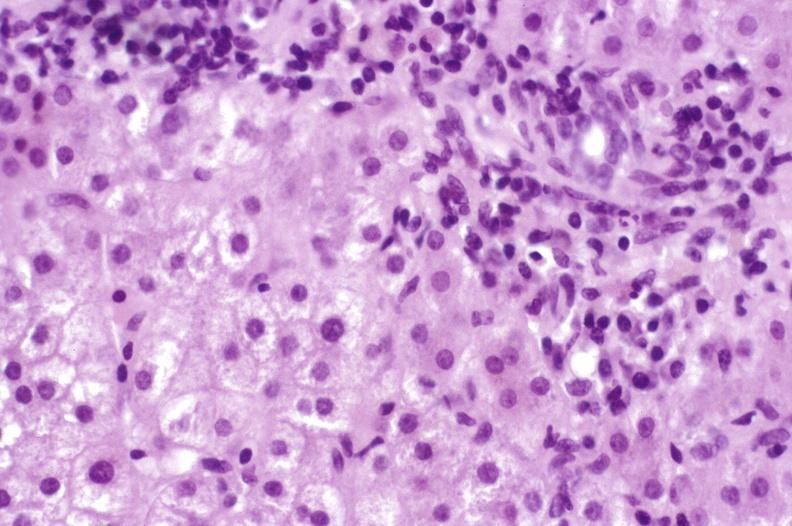what does this image show?
Answer the question using a single word or phrase. Primary biliary cirrhosis 